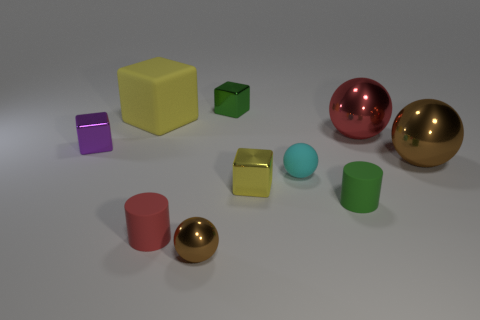Subtract all blocks. How many objects are left? 6 Add 9 big yellow rubber blocks. How many big yellow rubber blocks are left? 10 Add 9 small red shiny balls. How many small red shiny balls exist? 9 Subtract 1 yellow cubes. How many objects are left? 9 Subtract all small matte balls. Subtract all small cyan matte balls. How many objects are left? 8 